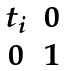<formula> <loc_0><loc_0><loc_500><loc_500>\begin{matrix} t _ { i } & 0 \\ 0 & 1 \end{matrix}</formula> 